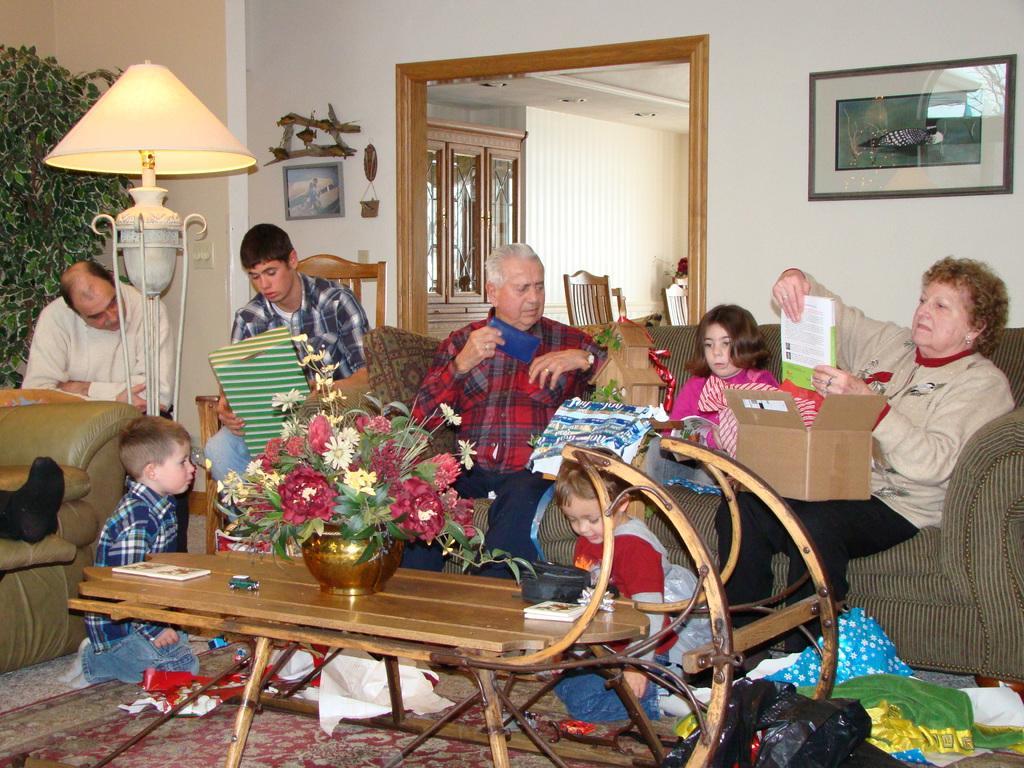How would you summarize this image in a sentence or two? This image is taken in a room. There are seven persons in this room, three kids and four adults. There is a lamp in the left side of the image, there is a sofa in the left side of the image, in the middle there is a floor mat on the floor. In the middle there is a table and a flower pot, flower vase on it. There is a book on the table, there is a plant on the left side of the image. There is a wall, there is a frame on the right side of the wall. There is a cardboard box on the woman's lap. There are empty chairs in the middle of the room, a man is sitting on a sofa in the middle of the room. 